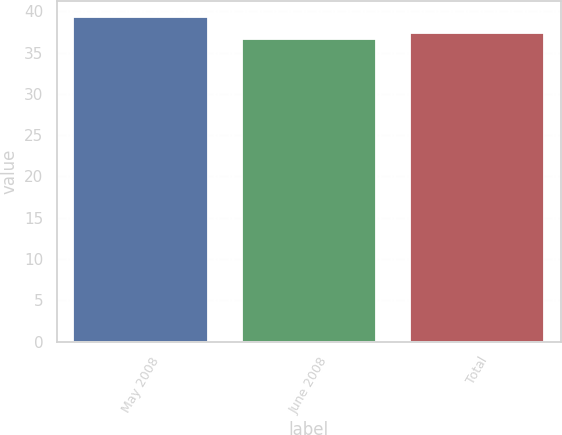Convert chart to OTSL. <chart><loc_0><loc_0><loc_500><loc_500><bar_chart><fcel>May 2008<fcel>June 2008<fcel>Total<nl><fcel>39.35<fcel>36.67<fcel>37.36<nl></chart> 